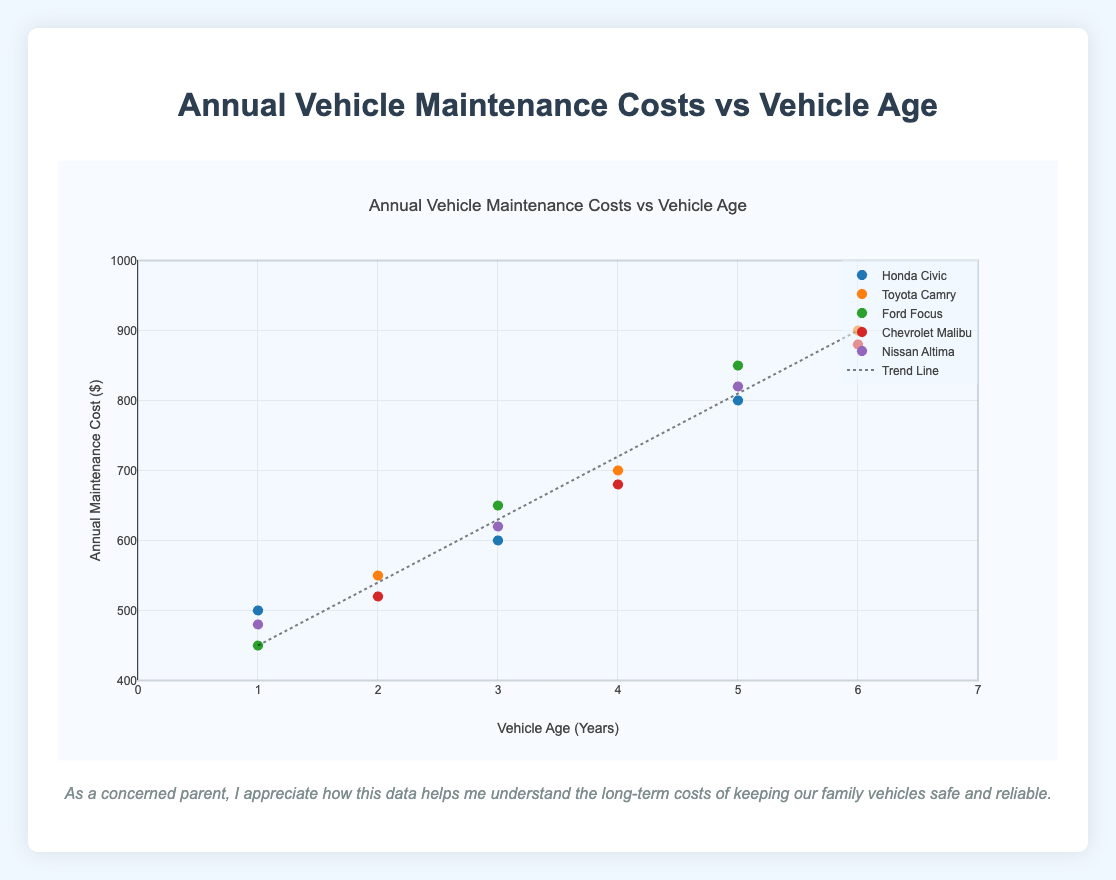What is the title of the plot? The title of the plot can be found at the top of the figure and it describes what the plot represents.
Answer: Annual Vehicle Maintenance Costs vs Vehicle Age What is the range of the x-axis in the plot? The x-axis represents the vehicle age in years, and its range is provided in the axis labels.
Answer: 0 to 7 years Which vehicle model appears to have the highest annual maintenance cost for the oldest vehicle age shown? To determine this, check the highest y-value point at the maximum x-value (vehicle age) and note the corresponding vehicle model.
Answer: Toyota Camry What is the general trend of maintenance costs as vehicle age increases? Refer to the trend line drawn through the data points, which indicates the overall direction of the data.
Answer: Maintenance costs generally increase Which vehicle model has the lowest annual maintenance cost for a 1-year-old vehicle? Find the point corresponding to a vehicle age of 1 year on the x-axis and then identify the vehicle model with the lowest y-value (maintenance cost) at that point.
Answer: Ford Focus By how much does the annual maintenance cost increase from a 1-year-old to a 5-year-old Honda Civic? Find the points for Honda Civic at vehicle ages of 1 and 5 years. Calculate the difference in their y-values (annual maintenance costs): 800 - 500 = 300.
Answer: $300 What is the average maintenance cost for 4-year-old vehicles? Identify all points where vehicle age is 4 years. Average the y-values (maintenance costs): (700 + 680) / 2 = 690.
Answer: $690 Which two vehicle models have similar annual maintenance costs for 3-year-old vehicles? Compare the y-values (annual maintenance costs) of different vehicle models at a vehicle age of 3 years. Identify the two models with close y-values.
Answer: Honda Civic and Nissan Altima Does any vehicle model have consistent annual maintenance costs at different vehicle ages? Examine the plot to see if any vehicle model’s points form a horizontal line, indicating no increase in maintenance costs with age.
Answer: No Based on the trend line, what can you infer about the future maintenance costs of a vehicle if the trend continues? The trend line shows a positive slope, suggesting that costs will continue to rise if the trend holds. This predicts higher maintenance costs as vehicles age further.
Answer: Maintenance costs will increase 